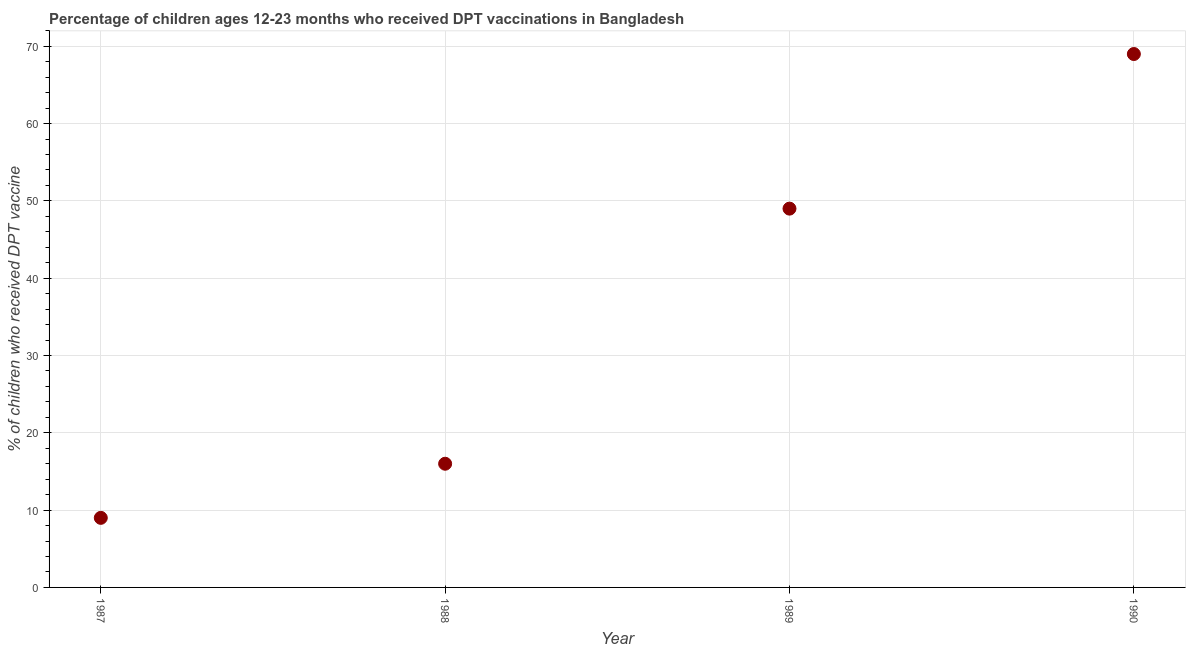What is the percentage of children who received dpt vaccine in 1988?
Keep it short and to the point. 16. Across all years, what is the maximum percentage of children who received dpt vaccine?
Your answer should be compact. 69. Across all years, what is the minimum percentage of children who received dpt vaccine?
Offer a very short reply. 9. In which year was the percentage of children who received dpt vaccine maximum?
Provide a succinct answer. 1990. In which year was the percentage of children who received dpt vaccine minimum?
Offer a very short reply. 1987. What is the sum of the percentage of children who received dpt vaccine?
Provide a succinct answer. 143. What is the difference between the percentage of children who received dpt vaccine in 1988 and 1989?
Provide a short and direct response. -33. What is the average percentage of children who received dpt vaccine per year?
Your response must be concise. 35.75. What is the median percentage of children who received dpt vaccine?
Provide a short and direct response. 32.5. In how many years, is the percentage of children who received dpt vaccine greater than 20 %?
Ensure brevity in your answer.  2. Do a majority of the years between 1990 and 1988 (inclusive) have percentage of children who received dpt vaccine greater than 50 %?
Offer a very short reply. No. What is the ratio of the percentage of children who received dpt vaccine in 1987 to that in 1988?
Your response must be concise. 0.56. Is the sum of the percentage of children who received dpt vaccine in 1989 and 1990 greater than the maximum percentage of children who received dpt vaccine across all years?
Provide a succinct answer. Yes. What is the difference between the highest and the lowest percentage of children who received dpt vaccine?
Offer a very short reply. 60. In how many years, is the percentage of children who received dpt vaccine greater than the average percentage of children who received dpt vaccine taken over all years?
Give a very brief answer. 2. Does the percentage of children who received dpt vaccine monotonically increase over the years?
Your response must be concise. Yes. What is the difference between two consecutive major ticks on the Y-axis?
Provide a succinct answer. 10. Does the graph contain any zero values?
Offer a very short reply. No. Does the graph contain grids?
Give a very brief answer. Yes. What is the title of the graph?
Provide a short and direct response. Percentage of children ages 12-23 months who received DPT vaccinations in Bangladesh. What is the label or title of the Y-axis?
Make the answer very short. % of children who received DPT vaccine. What is the % of children who received DPT vaccine in 1987?
Your answer should be very brief. 9. What is the % of children who received DPT vaccine in 1990?
Ensure brevity in your answer.  69. What is the difference between the % of children who received DPT vaccine in 1987 and 1988?
Keep it short and to the point. -7. What is the difference between the % of children who received DPT vaccine in 1987 and 1990?
Your answer should be compact. -60. What is the difference between the % of children who received DPT vaccine in 1988 and 1989?
Your answer should be very brief. -33. What is the difference between the % of children who received DPT vaccine in 1988 and 1990?
Give a very brief answer. -53. What is the ratio of the % of children who received DPT vaccine in 1987 to that in 1988?
Your answer should be very brief. 0.56. What is the ratio of the % of children who received DPT vaccine in 1987 to that in 1989?
Offer a terse response. 0.18. What is the ratio of the % of children who received DPT vaccine in 1987 to that in 1990?
Provide a short and direct response. 0.13. What is the ratio of the % of children who received DPT vaccine in 1988 to that in 1989?
Provide a succinct answer. 0.33. What is the ratio of the % of children who received DPT vaccine in 1988 to that in 1990?
Ensure brevity in your answer.  0.23. What is the ratio of the % of children who received DPT vaccine in 1989 to that in 1990?
Your answer should be compact. 0.71. 